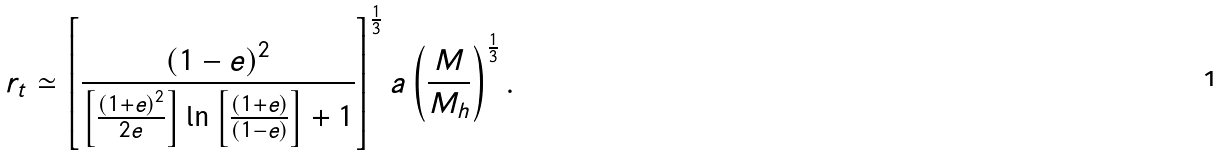<formula> <loc_0><loc_0><loc_500><loc_500>r _ { t } \simeq \left [ \frac { \left ( 1 - e \right ) ^ { 2 } } { \left [ \frac { \left ( 1 + e \right ) ^ { 2 } } { 2 e } \right ] \ln \left [ \frac { \left ( 1 + e \right ) } { \left ( 1 - e \right ) } \right ] + 1 } \right ] ^ { \frac { 1 } { 3 } } a \left ( \frac { M } { M _ { h } } \right ) ^ { \frac { 1 } { 3 } } .</formula> 